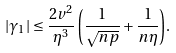Convert formula to latex. <formula><loc_0><loc_0><loc_500><loc_500>| \gamma _ { 1 } | \leq { \frac { 2 v ^ { 2 } } { \eta ^ { 3 } } \left ( \frac { 1 } { \sqrt { n p } } + \frac { 1 } { n \eta } \right ) } .</formula> 